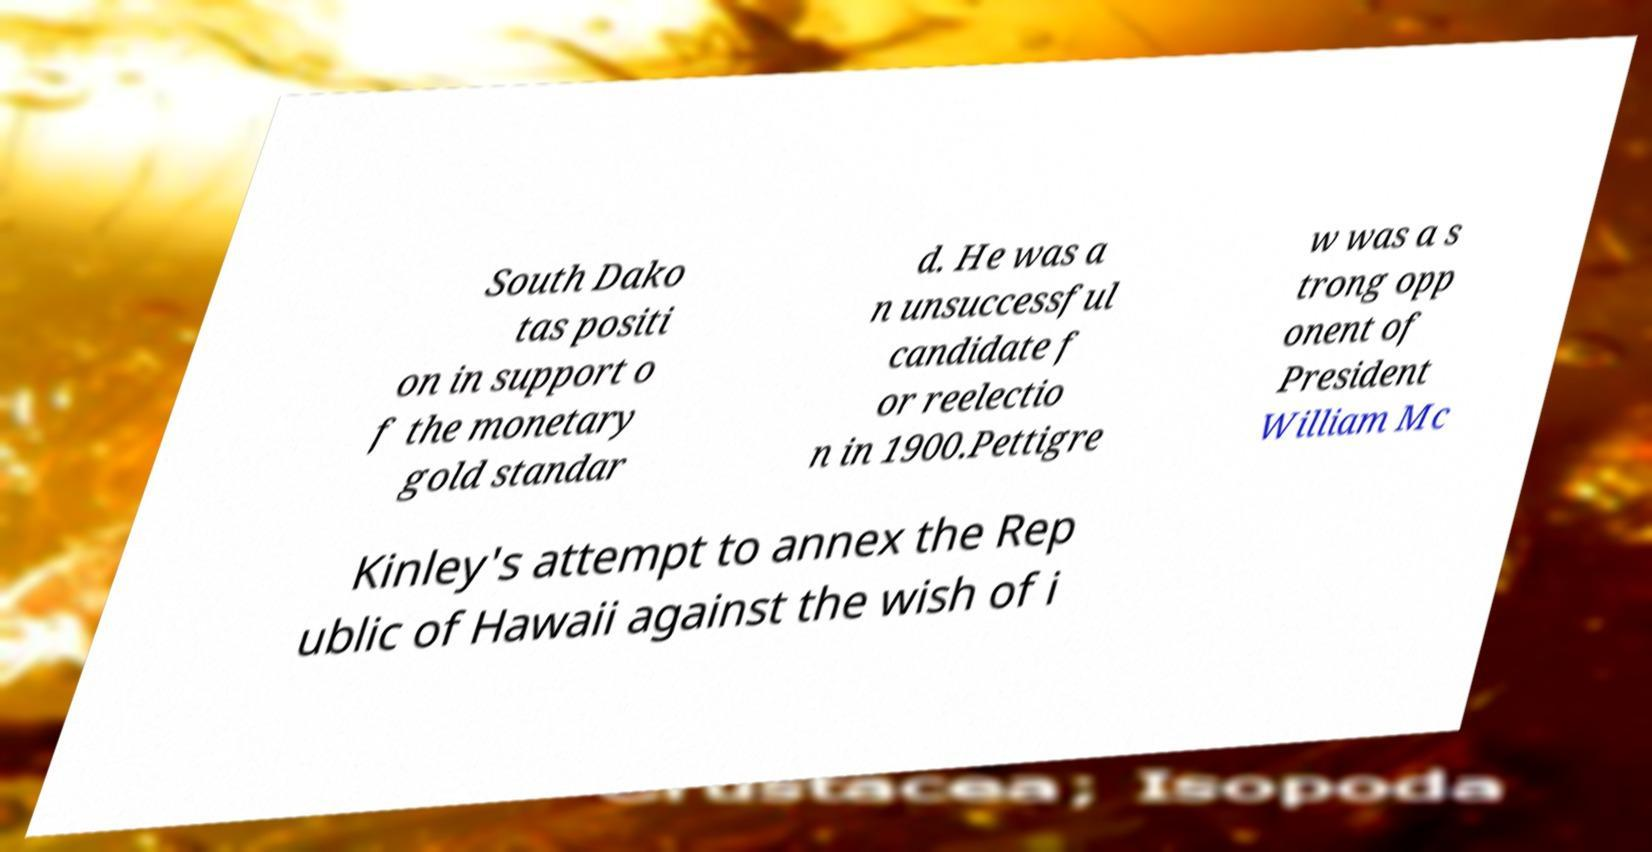Please read and relay the text visible in this image. What does it say? South Dako tas positi on in support o f the monetary gold standar d. He was a n unsuccessful candidate f or reelectio n in 1900.Pettigre w was a s trong opp onent of President William Mc Kinley's attempt to annex the Rep ublic of Hawaii against the wish of i 